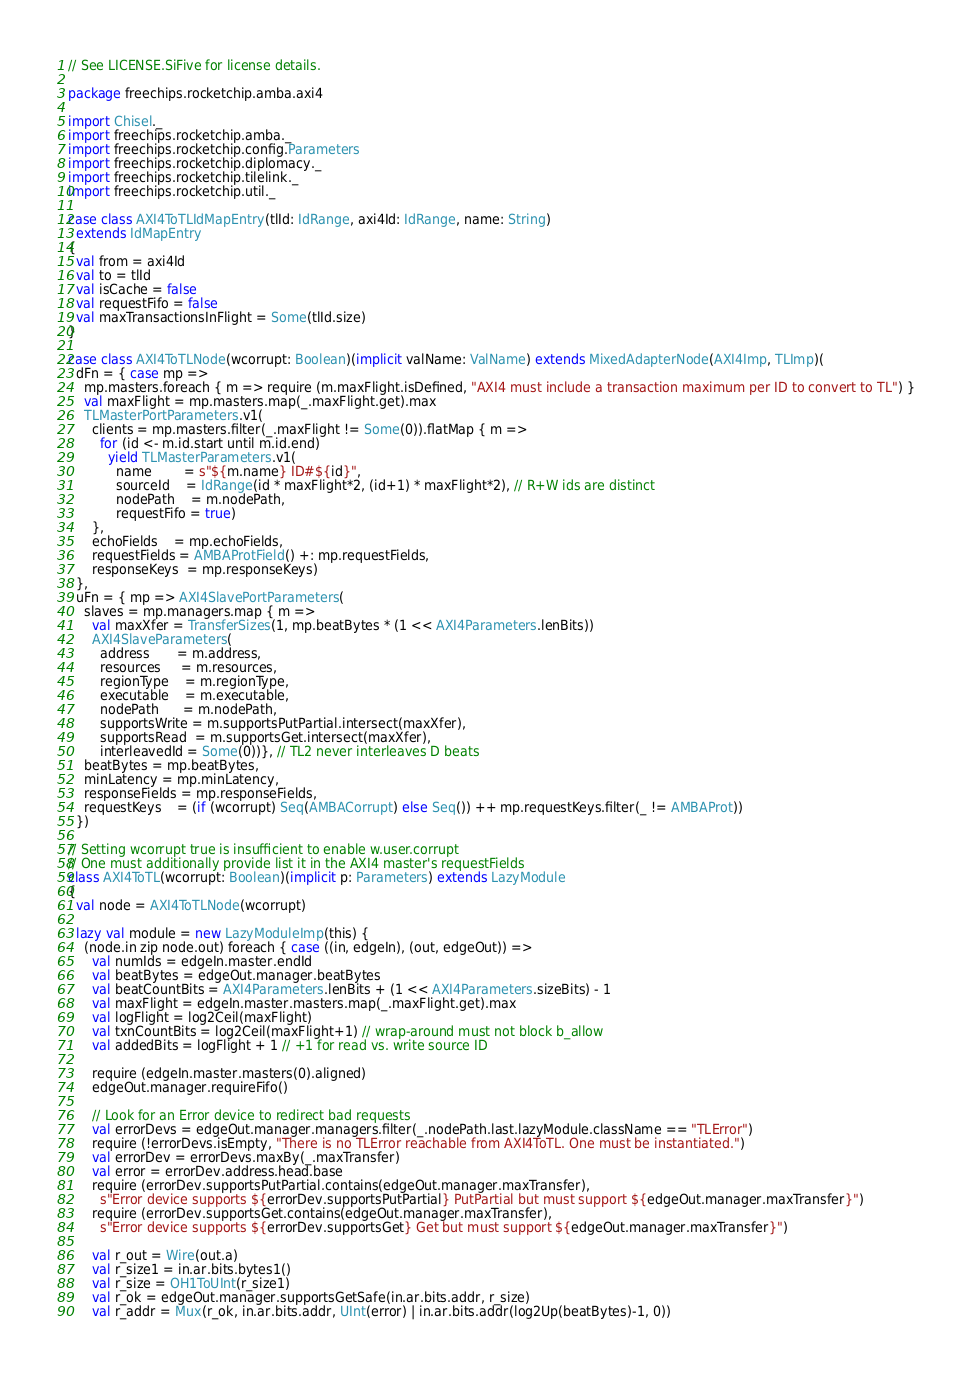<code> <loc_0><loc_0><loc_500><loc_500><_Scala_>// See LICENSE.SiFive for license details.

package freechips.rocketchip.amba.axi4

import Chisel._
import freechips.rocketchip.amba._
import freechips.rocketchip.config.Parameters
import freechips.rocketchip.diplomacy._
import freechips.rocketchip.tilelink._
import freechips.rocketchip.util._

case class AXI4ToTLIdMapEntry(tlId: IdRange, axi4Id: IdRange, name: String)
  extends IdMapEntry
{
  val from = axi4Id
  val to = tlId
  val isCache = false
  val requestFifo = false
  val maxTransactionsInFlight = Some(tlId.size)
}

case class AXI4ToTLNode(wcorrupt: Boolean)(implicit valName: ValName) extends MixedAdapterNode(AXI4Imp, TLImp)(
  dFn = { case mp =>
    mp.masters.foreach { m => require (m.maxFlight.isDefined, "AXI4 must include a transaction maximum per ID to convert to TL") }
    val maxFlight = mp.masters.map(_.maxFlight.get).max
    TLMasterPortParameters.v1(
      clients = mp.masters.filter(_.maxFlight != Some(0)).flatMap { m =>
        for (id <- m.id.start until m.id.end)
          yield TLMasterParameters.v1(
            name        = s"${m.name} ID#${id}",
            sourceId    = IdRange(id * maxFlight*2, (id+1) * maxFlight*2), // R+W ids are distinct
            nodePath    = m.nodePath,
            requestFifo = true)
      },
      echoFields    = mp.echoFields,
      requestFields = AMBAProtField() +: mp.requestFields,
      responseKeys  = mp.responseKeys)
  },
  uFn = { mp => AXI4SlavePortParameters(
    slaves = mp.managers.map { m =>
      val maxXfer = TransferSizes(1, mp.beatBytes * (1 << AXI4Parameters.lenBits))
      AXI4SlaveParameters(
        address       = m.address,
        resources     = m.resources,
        regionType    = m.regionType,
        executable    = m.executable,
        nodePath      = m.nodePath,
        supportsWrite = m.supportsPutPartial.intersect(maxXfer),
        supportsRead  = m.supportsGet.intersect(maxXfer),
        interleavedId = Some(0))}, // TL2 never interleaves D beats
    beatBytes = mp.beatBytes,
    minLatency = mp.minLatency,
    responseFields = mp.responseFields,
    requestKeys    = (if (wcorrupt) Seq(AMBACorrupt) else Seq()) ++ mp.requestKeys.filter(_ != AMBAProt))
  })

// Setting wcorrupt true is insufficient to enable w.user.corrupt
// One must additionally provide list it in the AXI4 master's requestFields
class AXI4ToTL(wcorrupt: Boolean)(implicit p: Parameters) extends LazyModule
{
  val node = AXI4ToTLNode(wcorrupt)

  lazy val module = new LazyModuleImp(this) {
    (node.in zip node.out) foreach { case ((in, edgeIn), (out, edgeOut)) =>
      val numIds = edgeIn.master.endId
      val beatBytes = edgeOut.manager.beatBytes
      val beatCountBits = AXI4Parameters.lenBits + (1 << AXI4Parameters.sizeBits) - 1
      val maxFlight = edgeIn.master.masters.map(_.maxFlight.get).max
      val logFlight = log2Ceil(maxFlight)
      val txnCountBits = log2Ceil(maxFlight+1) // wrap-around must not block b_allow
      val addedBits = logFlight + 1 // +1 for read vs. write source ID

      require (edgeIn.master.masters(0).aligned)
      edgeOut.manager.requireFifo()

      // Look for an Error device to redirect bad requests
      val errorDevs = edgeOut.manager.managers.filter(_.nodePath.last.lazyModule.className == "TLError")
      require (!errorDevs.isEmpty, "There is no TLError reachable from AXI4ToTL. One must be instantiated.")
      val errorDev = errorDevs.maxBy(_.maxTransfer)
      val error = errorDev.address.head.base
      require (errorDev.supportsPutPartial.contains(edgeOut.manager.maxTransfer),
        s"Error device supports ${errorDev.supportsPutPartial} PutPartial but must support ${edgeOut.manager.maxTransfer}")
      require (errorDev.supportsGet.contains(edgeOut.manager.maxTransfer),
        s"Error device supports ${errorDev.supportsGet} Get but must support ${edgeOut.manager.maxTransfer}")

      val r_out = Wire(out.a)
      val r_size1 = in.ar.bits.bytes1()
      val r_size = OH1ToUInt(r_size1)
      val r_ok = edgeOut.manager.supportsGetSafe(in.ar.bits.addr, r_size)
      val r_addr = Mux(r_ok, in.ar.bits.addr, UInt(error) | in.ar.bits.addr(log2Up(beatBytes)-1, 0))</code> 